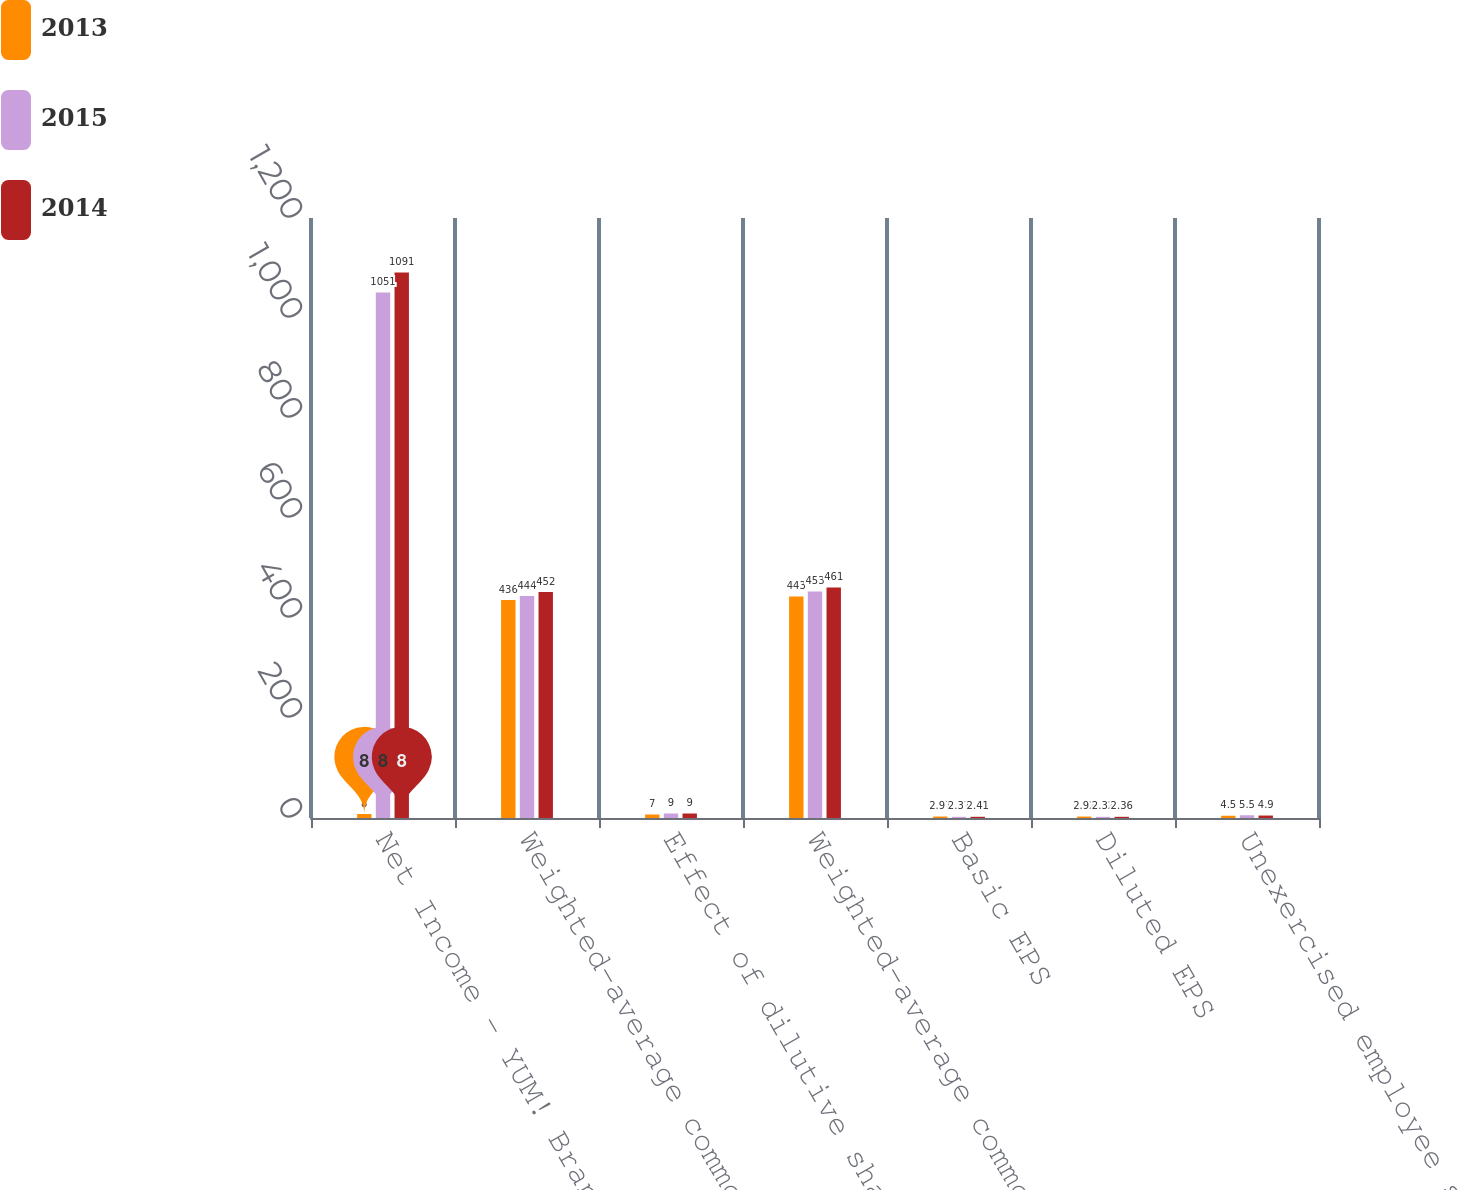<chart> <loc_0><loc_0><loc_500><loc_500><stacked_bar_chart><ecel><fcel>Net Income - YUM! Brands Inc<fcel>Weighted-average common shares<fcel>Effect of dilutive share-based<fcel>Weighted-average common and<fcel>Basic EPS<fcel>Diluted EPS<fcel>Unexercised employee stock<nl><fcel>2013<fcel>8<fcel>436<fcel>7<fcel>443<fcel>2.97<fcel>2.92<fcel>4.5<nl><fcel>2015<fcel>1051<fcel>444<fcel>9<fcel>453<fcel>2.37<fcel>2.32<fcel>5.5<nl><fcel>2014<fcel>1091<fcel>452<fcel>9<fcel>461<fcel>2.41<fcel>2.36<fcel>4.9<nl></chart> 